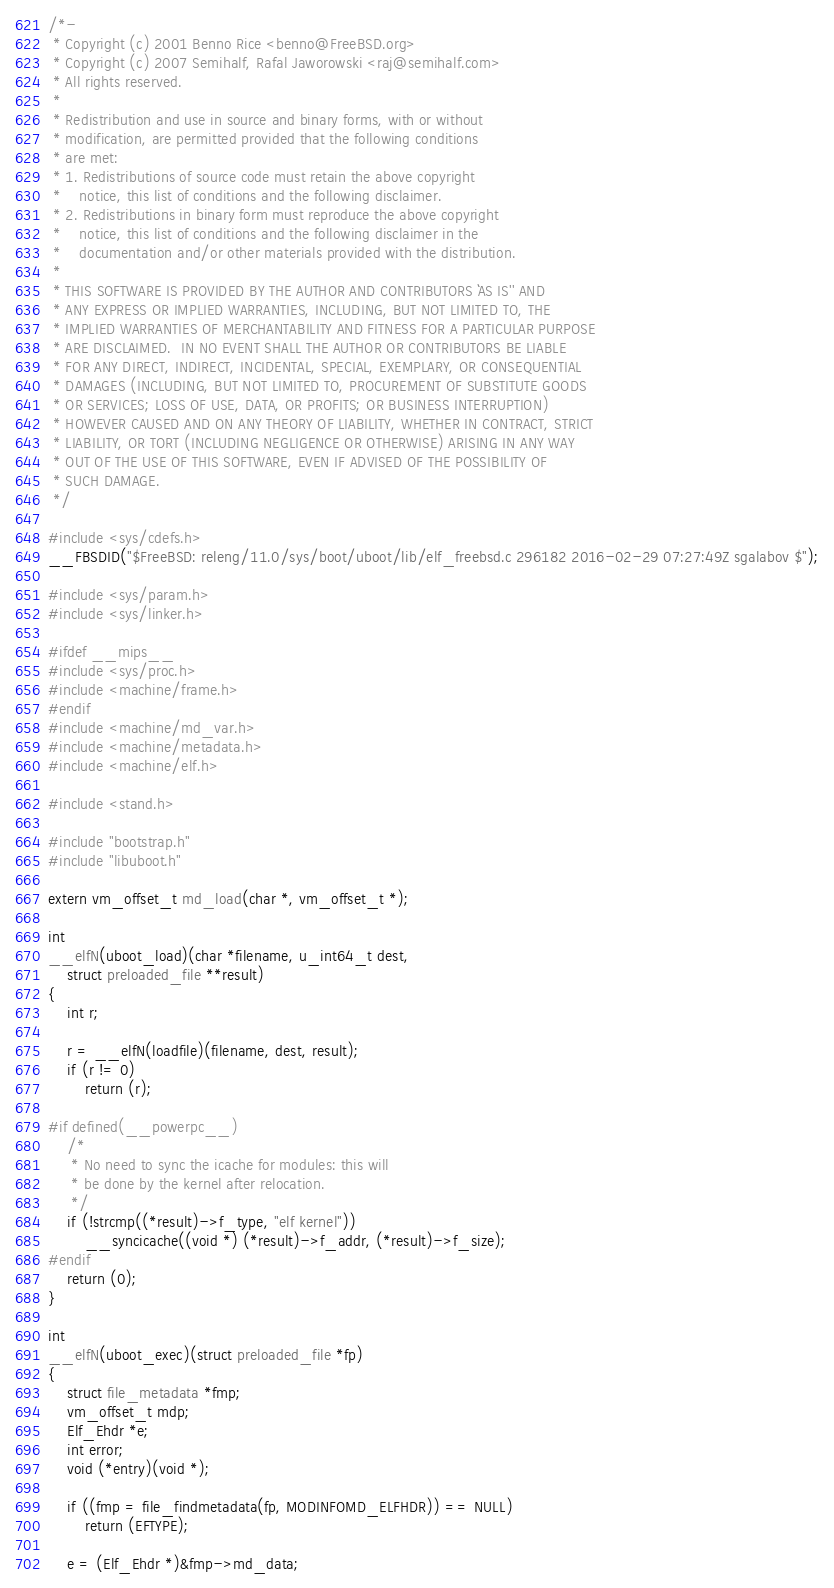Convert code to text. <code><loc_0><loc_0><loc_500><loc_500><_C_>/*-
 * Copyright (c) 2001 Benno Rice <benno@FreeBSD.org>
 * Copyright (c) 2007 Semihalf, Rafal Jaworowski <raj@semihalf.com>
 * All rights reserved.
 *
 * Redistribution and use in source and binary forms, with or without
 * modification, are permitted provided that the following conditions
 * are met:
 * 1. Redistributions of source code must retain the above copyright
 *    notice, this list of conditions and the following disclaimer.
 * 2. Redistributions in binary form must reproduce the above copyright
 *    notice, this list of conditions and the following disclaimer in the
 *    documentation and/or other materials provided with the distribution.
 *
 * THIS SOFTWARE IS PROVIDED BY THE AUTHOR AND CONTRIBUTORS ``AS IS'' AND
 * ANY EXPRESS OR IMPLIED WARRANTIES, INCLUDING, BUT NOT LIMITED TO, THE
 * IMPLIED WARRANTIES OF MERCHANTABILITY AND FITNESS FOR A PARTICULAR PURPOSE
 * ARE DISCLAIMED.  IN NO EVENT SHALL THE AUTHOR OR CONTRIBUTORS BE LIABLE
 * FOR ANY DIRECT, INDIRECT, INCIDENTAL, SPECIAL, EXEMPLARY, OR CONSEQUENTIAL
 * DAMAGES (INCLUDING, BUT NOT LIMITED TO, PROCUREMENT OF SUBSTITUTE GOODS
 * OR SERVICES; LOSS OF USE, DATA, OR PROFITS; OR BUSINESS INTERRUPTION)
 * HOWEVER CAUSED AND ON ANY THEORY OF LIABILITY, WHETHER IN CONTRACT, STRICT
 * LIABILITY, OR TORT (INCLUDING NEGLIGENCE OR OTHERWISE) ARISING IN ANY WAY
 * OUT OF THE USE OF THIS SOFTWARE, EVEN IF ADVISED OF THE POSSIBILITY OF
 * SUCH DAMAGE.
 */

#include <sys/cdefs.h>
__FBSDID("$FreeBSD: releng/11.0/sys/boot/uboot/lib/elf_freebsd.c 296182 2016-02-29 07:27:49Z sgalabov $");

#include <sys/param.h>
#include <sys/linker.h>

#ifdef __mips__
#include <sys/proc.h>
#include <machine/frame.h>
#endif
#include <machine/md_var.h>
#include <machine/metadata.h>
#include <machine/elf.h>

#include <stand.h>

#include "bootstrap.h"
#include "libuboot.h"

extern vm_offset_t md_load(char *, vm_offset_t *);

int
__elfN(uboot_load)(char *filename, u_int64_t dest,
    struct preloaded_file **result)
{
	int r;

	r = __elfN(loadfile)(filename, dest, result);
	if (r != 0)
		return (r);

#if defined(__powerpc__)
	/*
	 * No need to sync the icache for modules: this will
	 * be done by the kernel after relocation.
	 */
	if (!strcmp((*result)->f_type, "elf kernel"))
		__syncicache((void *) (*result)->f_addr, (*result)->f_size);
#endif
	return (0);
}

int
__elfN(uboot_exec)(struct preloaded_file *fp)
{
	struct file_metadata *fmp;
	vm_offset_t mdp;
	Elf_Ehdr *e;
	int error;
	void (*entry)(void *);

	if ((fmp = file_findmetadata(fp, MODINFOMD_ELFHDR)) == NULL)
		return (EFTYPE);

	e = (Elf_Ehdr *)&fmp->md_data;
</code> 